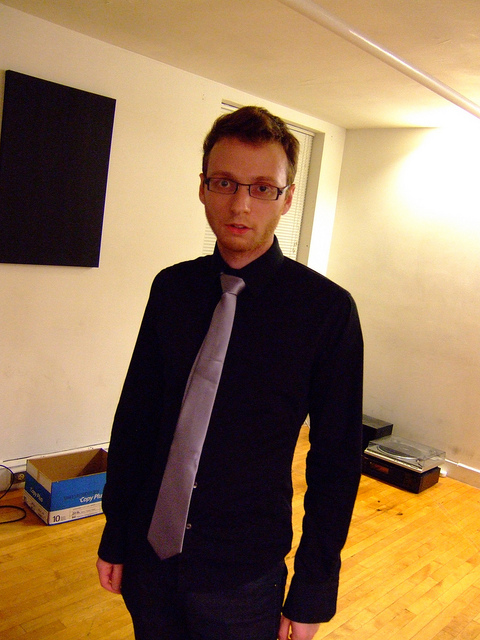What kind of lighting options would best complement this space? The space would benefit from a combination of ambient, task, and accent lighting to create a comfortable environment. A central ceiling fixture or standing lamps could provide general illumination, while focused lights like desk lamps or sconces can be used for reading or work. Accent lighting, such as LED strips or spotlights, can highlight artwork or architectural features, adding depth and interest to the room. 